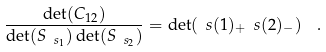<formula> <loc_0><loc_0><loc_500><loc_500>\frac { \det ( C _ { 1 2 } ) } { \det ( S _ { \ s _ { 1 } } ) \det ( S _ { \ s _ { 2 } } ) } = \det ( \ s ( 1 ) _ { + } \ s ( 2 ) _ { - } ) \ \ .</formula> 